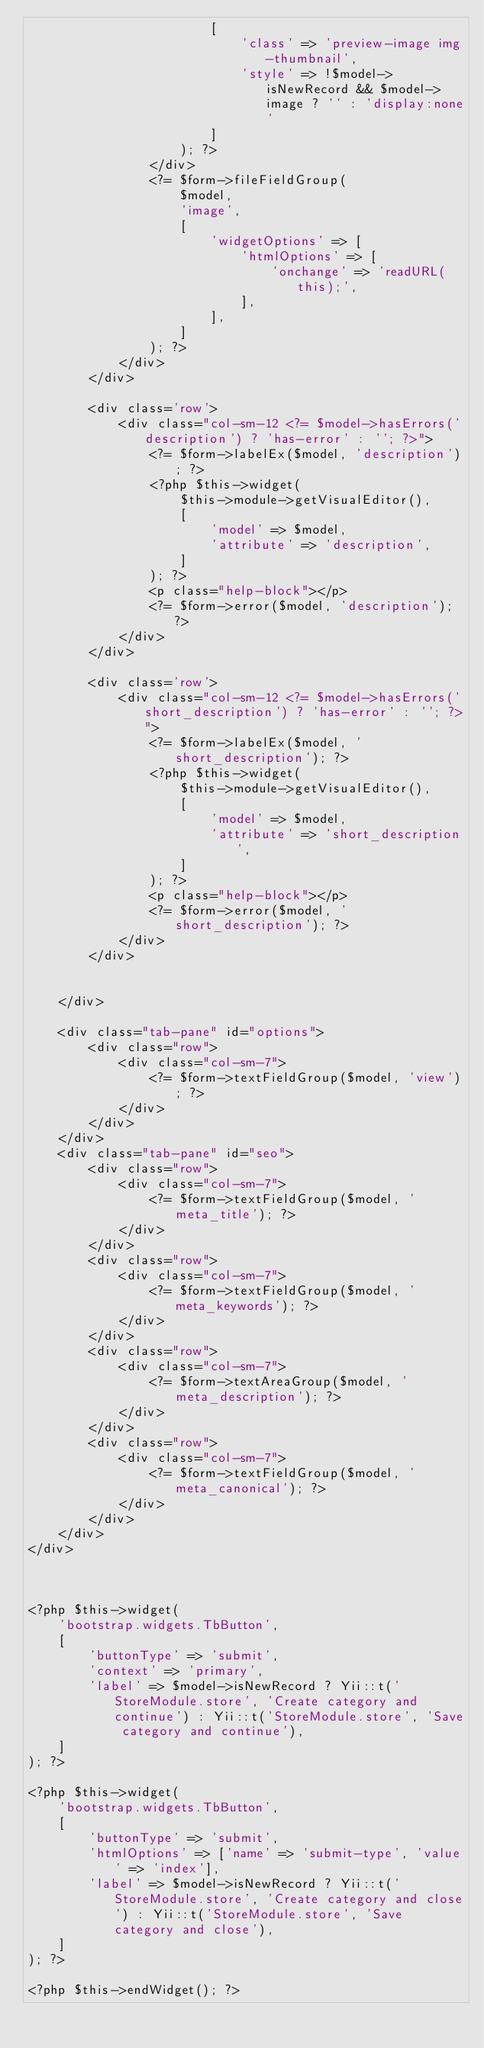<code> <loc_0><loc_0><loc_500><loc_500><_PHP_>                        [
                            'class' => 'preview-image img-thumbnail',
                            'style' => !$model->isNewRecord && $model->image ? '' : 'display:none'
                        ]
                    ); ?>
                </div>
                <?= $form->fileFieldGroup(
                    $model,
                    'image',
                    [
                        'widgetOptions' => [
                            'htmlOptions' => [
                                'onchange' => 'readURL(this);',
                            ],
                        ],
                    ]
                ); ?>
            </div>
        </div>

        <div class='row'>
            <div class="col-sm-12 <?= $model->hasErrors('description') ? 'has-error' : ''; ?>">
                <?= $form->labelEx($model, 'description'); ?>
                <?php $this->widget(
                    $this->module->getVisualEditor(),
                    [
                        'model' => $model,
                        'attribute' => 'description',
                    ]
                ); ?>
                <p class="help-block"></p>
                <?= $form->error($model, 'description'); ?>
            </div>
        </div>

        <div class='row'>
            <div class="col-sm-12 <?= $model->hasErrors('short_description') ? 'has-error' : ''; ?>">
                <?= $form->labelEx($model, 'short_description'); ?>
                <?php $this->widget(
                    $this->module->getVisualEditor(),
                    [
                        'model' => $model,
                        'attribute' => 'short_description',
                    ]
                ); ?>
                <p class="help-block"></p>
                <?= $form->error($model, 'short_description'); ?>
            </div>
        </div>


    </div>

    <div class="tab-pane" id="options">
        <div class="row">
            <div class="col-sm-7">
                <?= $form->textFieldGroup($model, 'view'); ?>
            </div>
        </div>
    </div>
    <div class="tab-pane" id="seo">
        <div class="row">
            <div class="col-sm-7">
                <?= $form->textFieldGroup($model, 'meta_title'); ?>
            </div>
        </div>
        <div class="row">
            <div class="col-sm-7">
                <?= $form->textFieldGroup($model, 'meta_keywords'); ?>
            </div>
        </div>
        <div class="row">
            <div class="col-sm-7">
                <?= $form->textAreaGroup($model, 'meta_description'); ?>
            </div>
        </div>
        <div class="row">
            <div class="col-sm-7">
                <?= $form->textFieldGroup($model, 'meta_canonical'); ?>
            </div>
        </div>
    </div>
</div>



<?php $this->widget(
    'bootstrap.widgets.TbButton',
    [
        'buttonType' => 'submit',
        'context' => 'primary',
        'label' => $model->isNewRecord ? Yii::t('StoreModule.store', 'Create category and continue') : Yii::t('StoreModule.store', 'Save category and continue'),
    ]
); ?>

<?php $this->widget(
    'bootstrap.widgets.TbButton',
    [
        'buttonType' => 'submit',
        'htmlOptions' => ['name' => 'submit-type', 'value' => 'index'],
        'label' => $model->isNewRecord ? Yii::t('StoreModule.store', 'Create category and close') : Yii::t('StoreModule.store', 'Save category and close'),
    ]
); ?>

<?php $this->endWidget(); ?>
</code> 